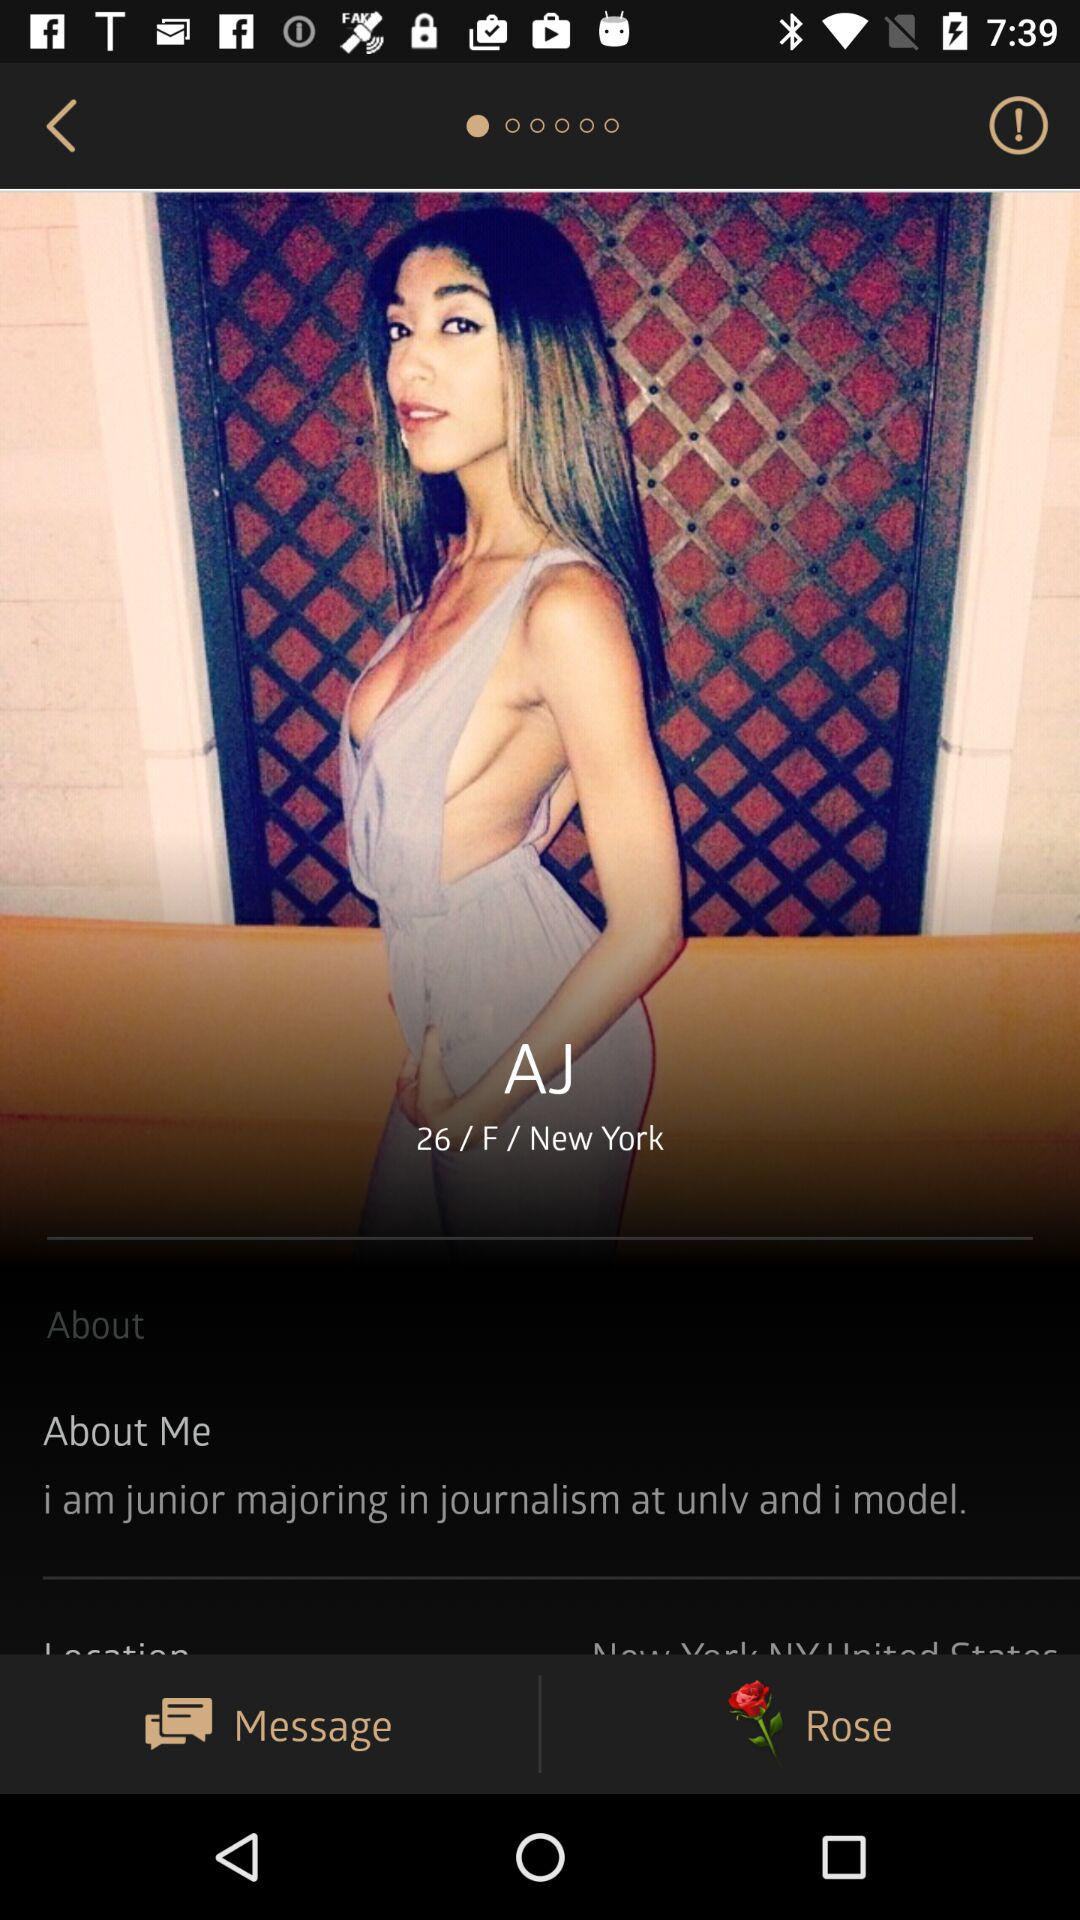What's the name? The name is "AJ". 